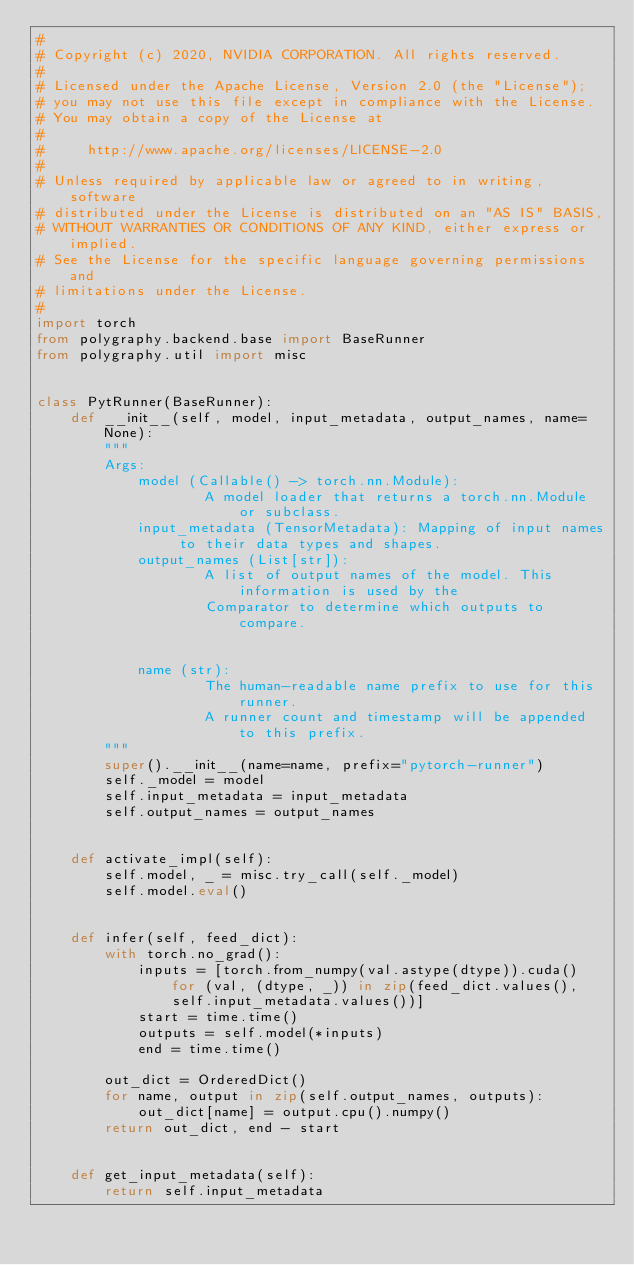<code> <loc_0><loc_0><loc_500><loc_500><_Python_>#
# Copyright (c) 2020, NVIDIA CORPORATION. All rights reserved.
#
# Licensed under the Apache License, Version 2.0 (the "License");
# you may not use this file except in compliance with the License.
# You may obtain a copy of the License at
#
#     http://www.apache.org/licenses/LICENSE-2.0
#
# Unless required by applicable law or agreed to in writing, software
# distributed under the License is distributed on an "AS IS" BASIS,
# WITHOUT WARRANTIES OR CONDITIONS OF ANY KIND, either express or implied.
# See the License for the specific language governing permissions and
# limitations under the License.
#
import torch
from polygraphy.backend.base import BaseRunner
from polygraphy.util import misc


class PytRunner(BaseRunner):
    def __init__(self, model, input_metadata, output_names, name=None):
        """
        Args:
            model (Callable() -> torch.nn.Module):
                    A model loader that returns a torch.nn.Module or subclass.
            input_metadata (TensorMetadata): Mapping of input names to their data types and shapes.
            output_names (List[str]):
                    A list of output names of the model. This information is used by the
                    Comparator to determine which outputs to compare.


            name (str):
                    The human-readable name prefix to use for this runner.
                    A runner count and timestamp will be appended to this prefix.
        """
        super().__init__(name=name, prefix="pytorch-runner")
        self._model = model
        self.input_metadata = input_metadata
        self.output_names = output_names


    def activate_impl(self):
        self.model, _ = misc.try_call(self._model)
        self.model.eval()


    def infer(self, feed_dict):
        with torch.no_grad():
            inputs = [torch.from_numpy(val.astype(dtype)).cuda() for (val, (dtype, _)) in zip(feed_dict.values(), self.input_metadata.values())]
            start = time.time()
            outputs = self.model(*inputs)
            end = time.time()

        out_dict = OrderedDict()
        for name, output in zip(self.output_names, outputs):
            out_dict[name] = output.cpu().numpy()
        return out_dict, end - start


    def get_input_metadata(self):
        return self.input_metadata
</code> 